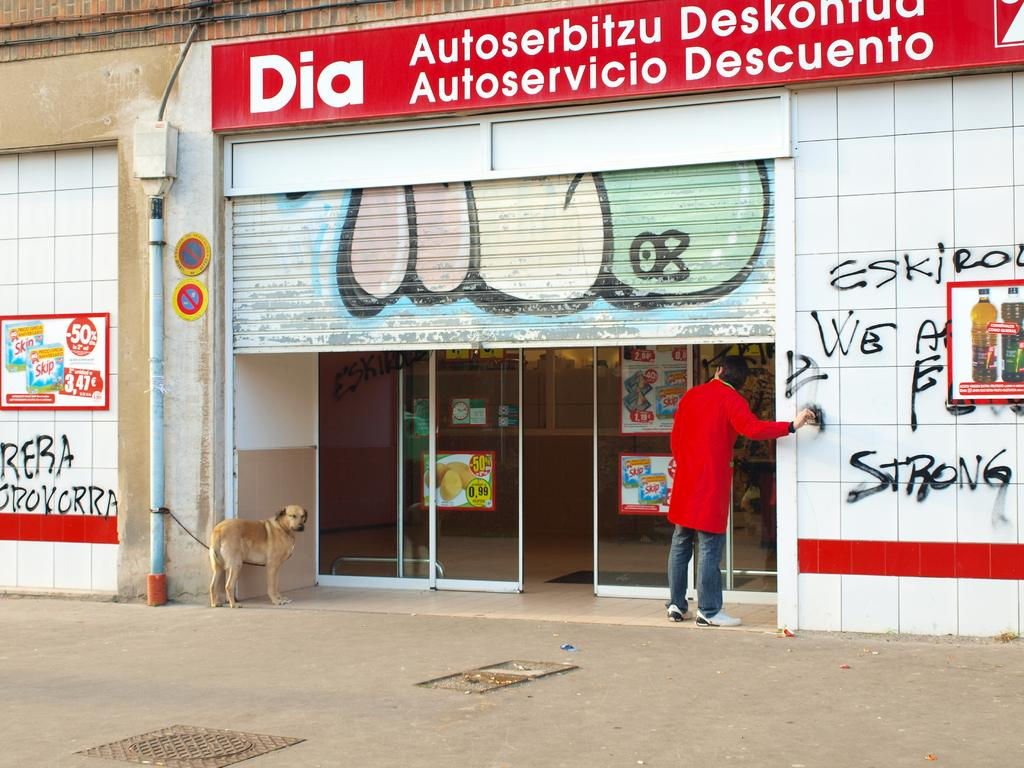What type of establishment is depicted in the image? There is a building in the image that appears to be a shop. Can you describe the person standing in front of the shop? There is a person standing in front of the shop. What is the dog in the image doing? The dog is tied with a rope to a pole in the image. What type of request is the dog making to the person in the image? There is no indication in the image that the dog is making any request, as dogs do not have the ability to communicate verbally. 